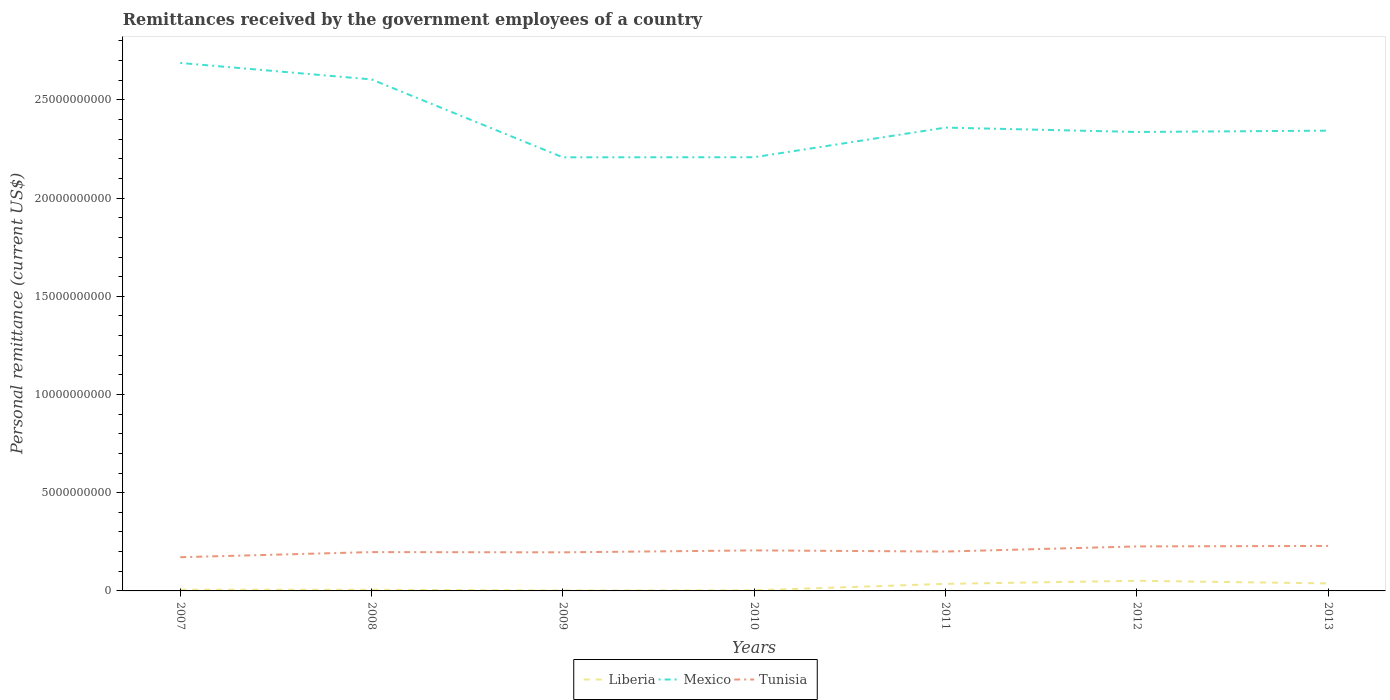How many different coloured lines are there?
Keep it short and to the point. 3. Does the line corresponding to Tunisia intersect with the line corresponding to Liberia?
Provide a short and direct response. No. Is the number of lines equal to the number of legend labels?
Give a very brief answer. Yes. Across all years, what is the maximum remittances received by the government employees in Mexico?
Give a very brief answer. 2.21e+1. What is the total remittances received by the government employees in Tunisia in the graph?
Ensure brevity in your answer.  -5.75e+08. What is the difference between the highest and the second highest remittances received by the government employees in Mexico?
Your answer should be compact. 4.80e+09. What is the difference between the highest and the lowest remittances received by the government employees in Mexico?
Provide a short and direct response. 2. How many years are there in the graph?
Your answer should be compact. 7. Does the graph contain any zero values?
Offer a very short reply. No. Does the graph contain grids?
Give a very brief answer. No. What is the title of the graph?
Provide a succinct answer. Remittances received by the government employees of a country. Does "Jamaica" appear as one of the legend labels in the graph?
Offer a very short reply. No. What is the label or title of the X-axis?
Give a very brief answer. Years. What is the label or title of the Y-axis?
Provide a succinct answer. Personal remittance (current US$). What is the Personal remittance (current US$) of Liberia in 2007?
Offer a very short reply. 6.20e+07. What is the Personal remittance (current US$) of Mexico in 2007?
Keep it short and to the point. 2.69e+1. What is the Personal remittance (current US$) in Tunisia in 2007?
Offer a very short reply. 1.72e+09. What is the Personal remittance (current US$) of Liberia in 2008?
Your answer should be very brief. 5.81e+07. What is the Personal remittance (current US$) of Mexico in 2008?
Provide a succinct answer. 2.60e+1. What is the Personal remittance (current US$) of Tunisia in 2008?
Your answer should be very brief. 1.98e+09. What is the Personal remittance (current US$) in Liberia in 2009?
Give a very brief answer. 2.51e+07. What is the Personal remittance (current US$) of Mexico in 2009?
Offer a very short reply. 2.21e+1. What is the Personal remittance (current US$) in Tunisia in 2009?
Your response must be concise. 1.96e+09. What is the Personal remittance (current US$) in Liberia in 2010?
Give a very brief answer. 3.14e+07. What is the Personal remittance (current US$) of Mexico in 2010?
Offer a terse response. 2.21e+1. What is the Personal remittance (current US$) in Tunisia in 2010?
Your answer should be very brief. 2.06e+09. What is the Personal remittance (current US$) of Liberia in 2011?
Ensure brevity in your answer.  3.60e+08. What is the Personal remittance (current US$) in Mexico in 2011?
Offer a very short reply. 2.36e+1. What is the Personal remittance (current US$) of Tunisia in 2011?
Make the answer very short. 2.00e+09. What is the Personal remittance (current US$) of Liberia in 2012?
Your response must be concise. 5.16e+08. What is the Personal remittance (current US$) in Mexico in 2012?
Provide a short and direct response. 2.34e+1. What is the Personal remittance (current US$) in Tunisia in 2012?
Provide a short and direct response. 2.27e+09. What is the Personal remittance (current US$) in Liberia in 2013?
Provide a short and direct response. 3.83e+08. What is the Personal remittance (current US$) in Mexico in 2013?
Give a very brief answer. 2.34e+1. What is the Personal remittance (current US$) in Tunisia in 2013?
Make the answer very short. 2.29e+09. Across all years, what is the maximum Personal remittance (current US$) in Liberia?
Give a very brief answer. 5.16e+08. Across all years, what is the maximum Personal remittance (current US$) of Mexico?
Provide a short and direct response. 2.69e+1. Across all years, what is the maximum Personal remittance (current US$) of Tunisia?
Offer a terse response. 2.29e+09. Across all years, what is the minimum Personal remittance (current US$) of Liberia?
Offer a very short reply. 2.51e+07. Across all years, what is the minimum Personal remittance (current US$) in Mexico?
Give a very brief answer. 2.21e+1. Across all years, what is the minimum Personal remittance (current US$) of Tunisia?
Ensure brevity in your answer.  1.72e+09. What is the total Personal remittance (current US$) in Liberia in the graph?
Offer a terse response. 1.44e+09. What is the total Personal remittance (current US$) of Mexico in the graph?
Provide a short and direct response. 1.67e+11. What is the total Personal remittance (current US$) of Tunisia in the graph?
Your answer should be compact. 1.43e+1. What is the difference between the Personal remittance (current US$) of Liberia in 2007 and that in 2008?
Your answer should be compact. 3.85e+06. What is the difference between the Personal remittance (current US$) of Mexico in 2007 and that in 2008?
Offer a terse response. 8.38e+08. What is the difference between the Personal remittance (current US$) of Tunisia in 2007 and that in 2008?
Keep it short and to the point. -2.61e+08. What is the difference between the Personal remittance (current US$) in Liberia in 2007 and that in 2009?
Provide a succinct answer. 3.69e+07. What is the difference between the Personal remittance (current US$) in Mexico in 2007 and that in 2009?
Your answer should be compact. 4.80e+09. What is the difference between the Personal remittance (current US$) in Tunisia in 2007 and that in 2009?
Offer a terse response. -2.49e+08. What is the difference between the Personal remittance (current US$) in Liberia in 2007 and that in 2010?
Provide a succinct answer. 3.05e+07. What is the difference between the Personal remittance (current US$) in Mexico in 2007 and that in 2010?
Make the answer very short. 4.80e+09. What is the difference between the Personal remittance (current US$) in Tunisia in 2007 and that in 2010?
Your answer should be compact. -3.48e+08. What is the difference between the Personal remittance (current US$) in Liberia in 2007 and that in 2011?
Your answer should be compact. -2.98e+08. What is the difference between the Personal remittance (current US$) in Mexico in 2007 and that in 2011?
Offer a very short reply. 3.29e+09. What is the difference between the Personal remittance (current US$) of Tunisia in 2007 and that in 2011?
Your response must be concise. -2.89e+08. What is the difference between the Personal remittance (current US$) of Liberia in 2007 and that in 2012?
Your response must be concise. -4.54e+08. What is the difference between the Personal remittance (current US$) in Mexico in 2007 and that in 2012?
Offer a terse response. 3.51e+09. What is the difference between the Personal remittance (current US$) of Tunisia in 2007 and that in 2012?
Provide a short and direct response. -5.50e+08. What is the difference between the Personal remittance (current US$) in Liberia in 2007 and that in 2013?
Ensure brevity in your answer.  -3.21e+08. What is the difference between the Personal remittance (current US$) of Mexico in 2007 and that in 2013?
Keep it short and to the point. 3.45e+09. What is the difference between the Personal remittance (current US$) of Tunisia in 2007 and that in 2013?
Offer a very short reply. -5.75e+08. What is the difference between the Personal remittance (current US$) of Liberia in 2008 and that in 2009?
Provide a succinct answer. 3.30e+07. What is the difference between the Personal remittance (current US$) in Mexico in 2008 and that in 2009?
Provide a short and direct response. 3.97e+09. What is the difference between the Personal remittance (current US$) of Tunisia in 2008 and that in 2009?
Your response must be concise. 1.25e+07. What is the difference between the Personal remittance (current US$) of Liberia in 2008 and that in 2010?
Offer a very short reply. 2.67e+07. What is the difference between the Personal remittance (current US$) in Mexico in 2008 and that in 2010?
Your answer should be compact. 3.96e+09. What is the difference between the Personal remittance (current US$) of Tunisia in 2008 and that in 2010?
Ensure brevity in your answer.  -8.63e+07. What is the difference between the Personal remittance (current US$) of Liberia in 2008 and that in 2011?
Offer a terse response. -3.02e+08. What is the difference between the Personal remittance (current US$) of Mexico in 2008 and that in 2011?
Your answer should be compact. 2.45e+09. What is the difference between the Personal remittance (current US$) in Tunisia in 2008 and that in 2011?
Provide a short and direct response. -2.75e+07. What is the difference between the Personal remittance (current US$) of Liberia in 2008 and that in 2012?
Offer a very short reply. -4.58e+08. What is the difference between the Personal remittance (current US$) of Mexico in 2008 and that in 2012?
Give a very brief answer. 2.68e+09. What is the difference between the Personal remittance (current US$) in Tunisia in 2008 and that in 2012?
Your answer should be very brief. -2.89e+08. What is the difference between the Personal remittance (current US$) in Liberia in 2008 and that in 2013?
Keep it short and to the point. -3.25e+08. What is the difference between the Personal remittance (current US$) of Mexico in 2008 and that in 2013?
Give a very brief answer. 2.61e+09. What is the difference between the Personal remittance (current US$) of Tunisia in 2008 and that in 2013?
Your response must be concise. -3.14e+08. What is the difference between the Personal remittance (current US$) of Liberia in 2009 and that in 2010?
Your response must be concise. -6.33e+06. What is the difference between the Personal remittance (current US$) in Mexico in 2009 and that in 2010?
Offer a terse response. -4.52e+06. What is the difference between the Personal remittance (current US$) in Tunisia in 2009 and that in 2010?
Give a very brief answer. -9.88e+07. What is the difference between the Personal remittance (current US$) of Liberia in 2009 and that in 2011?
Ensure brevity in your answer.  -3.35e+08. What is the difference between the Personal remittance (current US$) in Mexico in 2009 and that in 2011?
Make the answer very short. -1.51e+09. What is the difference between the Personal remittance (current US$) of Tunisia in 2009 and that in 2011?
Provide a succinct answer. -4.00e+07. What is the difference between the Personal remittance (current US$) of Liberia in 2009 and that in 2012?
Ensure brevity in your answer.  -4.91e+08. What is the difference between the Personal remittance (current US$) in Mexico in 2009 and that in 2012?
Give a very brief answer. -1.29e+09. What is the difference between the Personal remittance (current US$) of Tunisia in 2009 and that in 2012?
Give a very brief answer. -3.01e+08. What is the difference between the Personal remittance (current US$) of Liberia in 2009 and that in 2013?
Give a very brief answer. -3.58e+08. What is the difference between the Personal remittance (current US$) in Mexico in 2009 and that in 2013?
Offer a terse response. -1.36e+09. What is the difference between the Personal remittance (current US$) of Tunisia in 2009 and that in 2013?
Your answer should be compact. -3.26e+08. What is the difference between the Personal remittance (current US$) of Liberia in 2010 and that in 2011?
Offer a very short reply. -3.29e+08. What is the difference between the Personal remittance (current US$) of Mexico in 2010 and that in 2011?
Your answer should be compact. -1.51e+09. What is the difference between the Personal remittance (current US$) of Tunisia in 2010 and that in 2011?
Offer a very short reply. 5.88e+07. What is the difference between the Personal remittance (current US$) in Liberia in 2010 and that in 2012?
Provide a succinct answer. -4.84e+08. What is the difference between the Personal remittance (current US$) of Mexico in 2010 and that in 2012?
Ensure brevity in your answer.  -1.29e+09. What is the difference between the Personal remittance (current US$) of Tunisia in 2010 and that in 2012?
Give a very brief answer. -2.02e+08. What is the difference between the Personal remittance (current US$) of Liberia in 2010 and that in 2013?
Your answer should be very brief. -3.52e+08. What is the difference between the Personal remittance (current US$) in Mexico in 2010 and that in 2013?
Ensure brevity in your answer.  -1.35e+09. What is the difference between the Personal remittance (current US$) of Tunisia in 2010 and that in 2013?
Make the answer very short. -2.27e+08. What is the difference between the Personal remittance (current US$) in Liberia in 2011 and that in 2012?
Offer a very short reply. -1.56e+08. What is the difference between the Personal remittance (current US$) in Mexico in 2011 and that in 2012?
Keep it short and to the point. 2.22e+08. What is the difference between the Personal remittance (current US$) of Tunisia in 2011 and that in 2012?
Make the answer very short. -2.61e+08. What is the difference between the Personal remittance (current US$) of Liberia in 2011 and that in 2013?
Your answer should be very brief. -2.34e+07. What is the difference between the Personal remittance (current US$) in Mexico in 2011 and that in 2013?
Provide a succinct answer. 1.56e+08. What is the difference between the Personal remittance (current US$) in Tunisia in 2011 and that in 2013?
Your answer should be very brief. -2.86e+08. What is the difference between the Personal remittance (current US$) of Liberia in 2012 and that in 2013?
Your response must be concise. 1.32e+08. What is the difference between the Personal remittance (current US$) of Mexico in 2012 and that in 2013?
Your answer should be very brief. -6.69e+07. What is the difference between the Personal remittance (current US$) in Tunisia in 2012 and that in 2013?
Offer a very short reply. -2.48e+07. What is the difference between the Personal remittance (current US$) of Liberia in 2007 and the Personal remittance (current US$) of Mexico in 2008?
Offer a terse response. -2.60e+1. What is the difference between the Personal remittance (current US$) of Liberia in 2007 and the Personal remittance (current US$) of Tunisia in 2008?
Keep it short and to the point. -1.91e+09. What is the difference between the Personal remittance (current US$) in Mexico in 2007 and the Personal remittance (current US$) in Tunisia in 2008?
Give a very brief answer. 2.49e+1. What is the difference between the Personal remittance (current US$) of Liberia in 2007 and the Personal remittance (current US$) of Mexico in 2009?
Ensure brevity in your answer.  -2.20e+1. What is the difference between the Personal remittance (current US$) in Liberia in 2007 and the Personal remittance (current US$) in Tunisia in 2009?
Give a very brief answer. -1.90e+09. What is the difference between the Personal remittance (current US$) in Mexico in 2007 and the Personal remittance (current US$) in Tunisia in 2009?
Ensure brevity in your answer.  2.49e+1. What is the difference between the Personal remittance (current US$) of Liberia in 2007 and the Personal remittance (current US$) of Mexico in 2010?
Offer a terse response. -2.20e+1. What is the difference between the Personal remittance (current US$) in Liberia in 2007 and the Personal remittance (current US$) in Tunisia in 2010?
Give a very brief answer. -2.00e+09. What is the difference between the Personal remittance (current US$) in Mexico in 2007 and the Personal remittance (current US$) in Tunisia in 2010?
Provide a short and direct response. 2.48e+1. What is the difference between the Personal remittance (current US$) of Liberia in 2007 and the Personal remittance (current US$) of Mexico in 2011?
Ensure brevity in your answer.  -2.35e+1. What is the difference between the Personal remittance (current US$) in Liberia in 2007 and the Personal remittance (current US$) in Tunisia in 2011?
Ensure brevity in your answer.  -1.94e+09. What is the difference between the Personal remittance (current US$) of Mexico in 2007 and the Personal remittance (current US$) of Tunisia in 2011?
Your answer should be compact. 2.49e+1. What is the difference between the Personal remittance (current US$) in Liberia in 2007 and the Personal remittance (current US$) in Mexico in 2012?
Make the answer very short. -2.33e+1. What is the difference between the Personal remittance (current US$) of Liberia in 2007 and the Personal remittance (current US$) of Tunisia in 2012?
Offer a very short reply. -2.20e+09. What is the difference between the Personal remittance (current US$) in Mexico in 2007 and the Personal remittance (current US$) in Tunisia in 2012?
Give a very brief answer. 2.46e+1. What is the difference between the Personal remittance (current US$) in Liberia in 2007 and the Personal remittance (current US$) in Mexico in 2013?
Your response must be concise. -2.34e+1. What is the difference between the Personal remittance (current US$) of Liberia in 2007 and the Personal remittance (current US$) of Tunisia in 2013?
Give a very brief answer. -2.23e+09. What is the difference between the Personal remittance (current US$) of Mexico in 2007 and the Personal remittance (current US$) of Tunisia in 2013?
Give a very brief answer. 2.46e+1. What is the difference between the Personal remittance (current US$) in Liberia in 2008 and the Personal remittance (current US$) in Mexico in 2009?
Ensure brevity in your answer.  -2.20e+1. What is the difference between the Personal remittance (current US$) in Liberia in 2008 and the Personal remittance (current US$) in Tunisia in 2009?
Offer a terse response. -1.91e+09. What is the difference between the Personal remittance (current US$) of Mexico in 2008 and the Personal remittance (current US$) of Tunisia in 2009?
Ensure brevity in your answer.  2.41e+1. What is the difference between the Personal remittance (current US$) of Liberia in 2008 and the Personal remittance (current US$) of Mexico in 2010?
Give a very brief answer. -2.20e+1. What is the difference between the Personal remittance (current US$) of Liberia in 2008 and the Personal remittance (current US$) of Tunisia in 2010?
Provide a succinct answer. -2.01e+09. What is the difference between the Personal remittance (current US$) in Mexico in 2008 and the Personal remittance (current US$) in Tunisia in 2010?
Offer a very short reply. 2.40e+1. What is the difference between the Personal remittance (current US$) in Liberia in 2008 and the Personal remittance (current US$) in Mexico in 2011?
Your answer should be compact. -2.35e+1. What is the difference between the Personal remittance (current US$) of Liberia in 2008 and the Personal remittance (current US$) of Tunisia in 2011?
Offer a very short reply. -1.95e+09. What is the difference between the Personal remittance (current US$) in Mexico in 2008 and the Personal remittance (current US$) in Tunisia in 2011?
Your answer should be very brief. 2.40e+1. What is the difference between the Personal remittance (current US$) in Liberia in 2008 and the Personal remittance (current US$) in Mexico in 2012?
Provide a short and direct response. -2.33e+1. What is the difference between the Personal remittance (current US$) of Liberia in 2008 and the Personal remittance (current US$) of Tunisia in 2012?
Make the answer very short. -2.21e+09. What is the difference between the Personal remittance (current US$) of Mexico in 2008 and the Personal remittance (current US$) of Tunisia in 2012?
Make the answer very short. 2.38e+1. What is the difference between the Personal remittance (current US$) in Liberia in 2008 and the Personal remittance (current US$) in Mexico in 2013?
Provide a succinct answer. -2.34e+1. What is the difference between the Personal remittance (current US$) of Liberia in 2008 and the Personal remittance (current US$) of Tunisia in 2013?
Offer a terse response. -2.23e+09. What is the difference between the Personal remittance (current US$) of Mexico in 2008 and the Personal remittance (current US$) of Tunisia in 2013?
Provide a short and direct response. 2.38e+1. What is the difference between the Personal remittance (current US$) of Liberia in 2009 and the Personal remittance (current US$) of Mexico in 2010?
Offer a very short reply. -2.21e+1. What is the difference between the Personal remittance (current US$) in Liberia in 2009 and the Personal remittance (current US$) in Tunisia in 2010?
Offer a terse response. -2.04e+09. What is the difference between the Personal remittance (current US$) in Mexico in 2009 and the Personal remittance (current US$) in Tunisia in 2010?
Provide a short and direct response. 2.00e+1. What is the difference between the Personal remittance (current US$) in Liberia in 2009 and the Personal remittance (current US$) in Mexico in 2011?
Your answer should be compact. -2.36e+1. What is the difference between the Personal remittance (current US$) of Liberia in 2009 and the Personal remittance (current US$) of Tunisia in 2011?
Your answer should be very brief. -1.98e+09. What is the difference between the Personal remittance (current US$) of Mexico in 2009 and the Personal remittance (current US$) of Tunisia in 2011?
Offer a terse response. 2.01e+1. What is the difference between the Personal remittance (current US$) of Liberia in 2009 and the Personal remittance (current US$) of Mexico in 2012?
Make the answer very short. -2.33e+1. What is the difference between the Personal remittance (current US$) in Liberia in 2009 and the Personal remittance (current US$) in Tunisia in 2012?
Provide a succinct answer. -2.24e+09. What is the difference between the Personal remittance (current US$) of Mexico in 2009 and the Personal remittance (current US$) of Tunisia in 2012?
Give a very brief answer. 1.98e+1. What is the difference between the Personal remittance (current US$) of Liberia in 2009 and the Personal remittance (current US$) of Mexico in 2013?
Keep it short and to the point. -2.34e+1. What is the difference between the Personal remittance (current US$) in Liberia in 2009 and the Personal remittance (current US$) in Tunisia in 2013?
Ensure brevity in your answer.  -2.27e+09. What is the difference between the Personal remittance (current US$) of Mexico in 2009 and the Personal remittance (current US$) of Tunisia in 2013?
Give a very brief answer. 1.98e+1. What is the difference between the Personal remittance (current US$) in Liberia in 2010 and the Personal remittance (current US$) in Mexico in 2011?
Your response must be concise. -2.36e+1. What is the difference between the Personal remittance (current US$) of Liberia in 2010 and the Personal remittance (current US$) of Tunisia in 2011?
Offer a very short reply. -1.97e+09. What is the difference between the Personal remittance (current US$) in Mexico in 2010 and the Personal remittance (current US$) in Tunisia in 2011?
Make the answer very short. 2.01e+1. What is the difference between the Personal remittance (current US$) in Liberia in 2010 and the Personal remittance (current US$) in Mexico in 2012?
Provide a succinct answer. -2.33e+1. What is the difference between the Personal remittance (current US$) in Liberia in 2010 and the Personal remittance (current US$) in Tunisia in 2012?
Make the answer very short. -2.23e+09. What is the difference between the Personal remittance (current US$) in Mexico in 2010 and the Personal remittance (current US$) in Tunisia in 2012?
Provide a short and direct response. 1.98e+1. What is the difference between the Personal remittance (current US$) of Liberia in 2010 and the Personal remittance (current US$) of Mexico in 2013?
Provide a succinct answer. -2.34e+1. What is the difference between the Personal remittance (current US$) in Liberia in 2010 and the Personal remittance (current US$) in Tunisia in 2013?
Your answer should be compact. -2.26e+09. What is the difference between the Personal remittance (current US$) in Mexico in 2010 and the Personal remittance (current US$) in Tunisia in 2013?
Your response must be concise. 1.98e+1. What is the difference between the Personal remittance (current US$) of Liberia in 2011 and the Personal remittance (current US$) of Mexico in 2012?
Provide a succinct answer. -2.30e+1. What is the difference between the Personal remittance (current US$) in Liberia in 2011 and the Personal remittance (current US$) in Tunisia in 2012?
Offer a very short reply. -1.91e+09. What is the difference between the Personal remittance (current US$) of Mexico in 2011 and the Personal remittance (current US$) of Tunisia in 2012?
Offer a very short reply. 2.13e+1. What is the difference between the Personal remittance (current US$) in Liberia in 2011 and the Personal remittance (current US$) in Mexico in 2013?
Your response must be concise. -2.31e+1. What is the difference between the Personal remittance (current US$) of Liberia in 2011 and the Personal remittance (current US$) of Tunisia in 2013?
Offer a terse response. -1.93e+09. What is the difference between the Personal remittance (current US$) in Mexico in 2011 and the Personal remittance (current US$) in Tunisia in 2013?
Make the answer very short. 2.13e+1. What is the difference between the Personal remittance (current US$) of Liberia in 2012 and the Personal remittance (current US$) of Mexico in 2013?
Your answer should be very brief. -2.29e+1. What is the difference between the Personal remittance (current US$) of Liberia in 2012 and the Personal remittance (current US$) of Tunisia in 2013?
Your response must be concise. -1.77e+09. What is the difference between the Personal remittance (current US$) in Mexico in 2012 and the Personal remittance (current US$) in Tunisia in 2013?
Give a very brief answer. 2.11e+1. What is the average Personal remittance (current US$) of Liberia per year?
Provide a succinct answer. 2.05e+08. What is the average Personal remittance (current US$) of Mexico per year?
Your response must be concise. 2.39e+1. What is the average Personal remittance (current US$) in Tunisia per year?
Provide a short and direct response. 2.04e+09. In the year 2007, what is the difference between the Personal remittance (current US$) of Liberia and Personal remittance (current US$) of Mexico?
Ensure brevity in your answer.  -2.68e+1. In the year 2007, what is the difference between the Personal remittance (current US$) in Liberia and Personal remittance (current US$) in Tunisia?
Your response must be concise. -1.65e+09. In the year 2007, what is the difference between the Personal remittance (current US$) in Mexico and Personal remittance (current US$) in Tunisia?
Provide a short and direct response. 2.52e+1. In the year 2008, what is the difference between the Personal remittance (current US$) in Liberia and Personal remittance (current US$) in Mexico?
Keep it short and to the point. -2.60e+1. In the year 2008, what is the difference between the Personal remittance (current US$) in Liberia and Personal remittance (current US$) in Tunisia?
Provide a short and direct response. -1.92e+09. In the year 2008, what is the difference between the Personal remittance (current US$) of Mexico and Personal remittance (current US$) of Tunisia?
Your response must be concise. 2.41e+1. In the year 2009, what is the difference between the Personal remittance (current US$) in Liberia and Personal remittance (current US$) in Mexico?
Offer a terse response. -2.21e+1. In the year 2009, what is the difference between the Personal remittance (current US$) of Liberia and Personal remittance (current US$) of Tunisia?
Provide a succinct answer. -1.94e+09. In the year 2009, what is the difference between the Personal remittance (current US$) in Mexico and Personal remittance (current US$) in Tunisia?
Ensure brevity in your answer.  2.01e+1. In the year 2010, what is the difference between the Personal remittance (current US$) in Liberia and Personal remittance (current US$) in Mexico?
Keep it short and to the point. -2.20e+1. In the year 2010, what is the difference between the Personal remittance (current US$) of Liberia and Personal remittance (current US$) of Tunisia?
Your answer should be compact. -2.03e+09. In the year 2010, what is the difference between the Personal remittance (current US$) of Mexico and Personal remittance (current US$) of Tunisia?
Your response must be concise. 2.00e+1. In the year 2011, what is the difference between the Personal remittance (current US$) of Liberia and Personal remittance (current US$) of Mexico?
Ensure brevity in your answer.  -2.32e+1. In the year 2011, what is the difference between the Personal remittance (current US$) of Liberia and Personal remittance (current US$) of Tunisia?
Offer a terse response. -1.64e+09. In the year 2011, what is the difference between the Personal remittance (current US$) of Mexico and Personal remittance (current US$) of Tunisia?
Your answer should be very brief. 2.16e+1. In the year 2012, what is the difference between the Personal remittance (current US$) of Liberia and Personal remittance (current US$) of Mexico?
Make the answer very short. -2.29e+1. In the year 2012, what is the difference between the Personal remittance (current US$) in Liberia and Personal remittance (current US$) in Tunisia?
Provide a succinct answer. -1.75e+09. In the year 2012, what is the difference between the Personal remittance (current US$) of Mexico and Personal remittance (current US$) of Tunisia?
Offer a very short reply. 2.11e+1. In the year 2013, what is the difference between the Personal remittance (current US$) of Liberia and Personal remittance (current US$) of Mexico?
Offer a very short reply. -2.30e+1. In the year 2013, what is the difference between the Personal remittance (current US$) of Liberia and Personal remittance (current US$) of Tunisia?
Provide a succinct answer. -1.91e+09. In the year 2013, what is the difference between the Personal remittance (current US$) in Mexico and Personal remittance (current US$) in Tunisia?
Offer a terse response. 2.11e+1. What is the ratio of the Personal remittance (current US$) in Liberia in 2007 to that in 2008?
Make the answer very short. 1.07. What is the ratio of the Personal remittance (current US$) in Mexico in 2007 to that in 2008?
Provide a succinct answer. 1.03. What is the ratio of the Personal remittance (current US$) in Tunisia in 2007 to that in 2008?
Ensure brevity in your answer.  0.87. What is the ratio of the Personal remittance (current US$) of Liberia in 2007 to that in 2009?
Your answer should be compact. 2.47. What is the ratio of the Personal remittance (current US$) of Mexico in 2007 to that in 2009?
Your response must be concise. 1.22. What is the ratio of the Personal remittance (current US$) of Tunisia in 2007 to that in 2009?
Make the answer very short. 0.87. What is the ratio of the Personal remittance (current US$) of Liberia in 2007 to that in 2010?
Make the answer very short. 1.97. What is the ratio of the Personal remittance (current US$) of Mexico in 2007 to that in 2010?
Provide a short and direct response. 1.22. What is the ratio of the Personal remittance (current US$) in Tunisia in 2007 to that in 2010?
Your response must be concise. 0.83. What is the ratio of the Personal remittance (current US$) of Liberia in 2007 to that in 2011?
Provide a short and direct response. 0.17. What is the ratio of the Personal remittance (current US$) in Mexico in 2007 to that in 2011?
Your response must be concise. 1.14. What is the ratio of the Personal remittance (current US$) in Tunisia in 2007 to that in 2011?
Offer a very short reply. 0.86. What is the ratio of the Personal remittance (current US$) in Liberia in 2007 to that in 2012?
Make the answer very short. 0.12. What is the ratio of the Personal remittance (current US$) of Mexico in 2007 to that in 2012?
Keep it short and to the point. 1.15. What is the ratio of the Personal remittance (current US$) in Tunisia in 2007 to that in 2012?
Ensure brevity in your answer.  0.76. What is the ratio of the Personal remittance (current US$) of Liberia in 2007 to that in 2013?
Offer a terse response. 0.16. What is the ratio of the Personal remittance (current US$) in Mexico in 2007 to that in 2013?
Offer a terse response. 1.15. What is the ratio of the Personal remittance (current US$) of Tunisia in 2007 to that in 2013?
Provide a succinct answer. 0.75. What is the ratio of the Personal remittance (current US$) in Liberia in 2008 to that in 2009?
Make the answer very short. 2.31. What is the ratio of the Personal remittance (current US$) of Mexico in 2008 to that in 2009?
Offer a terse response. 1.18. What is the ratio of the Personal remittance (current US$) of Tunisia in 2008 to that in 2009?
Provide a succinct answer. 1.01. What is the ratio of the Personal remittance (current US$) in Liberia in 2008 to that in 2010?
Your response must be concise. 1.85. What is the ratio of the Personal remittance (current US$) of Mexico in 2008 to that in 2010?
Keep it short and to the point. 1.18. What is the ratio of the Personal remittance (current US$) of Tunisia in 2008 to that in 2010?
Your answer should be very brief. 0.96. What is the ratio of the Personal remittance (current US$) of Liberia in 2008 to that in 2011?
Offer a terse response. 0.16. What is the ratio of the Personal remittance (current US$) of Mexico in 2008 to that in 2011?
Ensure brevity in your answer.  1.1. What is the ratio of the Personal remittance (current US$) of Tunisia in 2008 to that in 2011?
Provide a short and direct response. 0.99. What is the ratio of the Personal remittance (current US$) of Liberia in 2008 to that in 2012?
Offer a very short reply. 0.11. What is the ratio of the Personal remittance (current US$) of Mexico in 2008 to that in 2012?
Provide a succinct answer. 1.11. What is the ratio of the Personal remittance (current US$) in Tunisia in 2008 to that in 2012?
Make the answer very short. 0.87. What is the ratio of the Personal remittance (current US$) in Liberia in 2008 to that in 2013?
Provide a succinct answer. 0.15. What is the ratio of the Personal remittance (current US$) of Mexico in 2008 to that in 2013?
Provide a succinct answer. 1.11. What is the ratio of the Personal remittance (current US$) of Tunisia in 2008 to that in 2013?
Give a very brief answer. 0.86. What is the ratio of the Personal remittance (current US$) of Liberia in 2009 to that in 2010?
Keep it short and to the point. 0.8. What is the ratio of the Personal remittance (current US$) in Tunisia in 2009 to that in 2010?
Give a very brief answer. 0.95. What is the ratio of the Personal remittance (current US$) in Liberia in 2009 to that in 2011?
Ensure brevity in your answer.  0.07. What is the ratio of the Personal remittance (current US$) of Mexico in 2009 to that in 2011?
Make the answer very short. 0.94. What is the ratio of the Personal remittance (current US$) of Liberia in 2009 to that in 2012?
Provide a succinct answer. 0.05. What is the ratio of the Personal remittance (current US$) of Mexico in 2009 to that in 2012?
Make the answer very short. 0.94. What is the ratio of the Personal remittance (current US$) in Tunisia in 2009 to that in 2012?
Your answer should be compact. 0.87. What is the ratio of the Personal remittance (current US$) in Liberia in 2009 to that in 2013?
Your answer should be compact. 0.07. What is the ratio of the Personal remittance (current US$) in Mexico in 2009 to that in 2013?
Keep it short and to the point. 0.94. What is the ratio of the Personal remittance (current US$) of Tunisia in 2009 to that in 2013?
Your answer should be very brief. 0.86. What is the ratio of the Personal remittance (current US$) of Liberia in 2010 to that in 2011?
Provide a succinct answer. 0.09. What is the ratio of the Personal remittance (current US$) in Mexico in 2010 to that in 2011?
Your answer should be very brief. 0.94. What is the ratio of the Personal remittance (current US$) in Tunisia in 2010 to that in 2011?
Make the answer very short. 1.03. What is the ratio of the Personal remittance (current US$) of Liberia in 2010 to that in 2012?
Ensure brevity in your answer.  0.06. What is the ratio of the Personal remittance (current US$) of Mexico in 2010 to that in 2012?
Provide a succinct answer. 0.94. What is the ratio of the Personal remittance (current US$) in Tunisia in 2010 to that in 2012?
Ensure brevity in your answer.  0.91. What is the ratio of the Personal remittance (current US$) of Liberia in 2010 to that in 2013?
Give a very brief answer. 0.08. What is the ratio of the Personal remittance (current US$) in Mexico in 2010 to that in 2013?
Your response must be concise. 0.94. What is the ratio of the Personal remittance (current US$) in Tunisia in 2010 to that in 2013?
Make the answer very short. 0.9. What is the ratio of the Personal remittance (current US$) of Liberia in 2011 to that in 2012?
Make the answer very short. 0.7. What is the ratio of the Personal remittance (current US$) in Mexico in 2011 to that in 2012?
Ensure brevity in your answer.  1.01. What is the ratio of the Personal remittance (current US$) of Tunisia in 2011 to that in 2012?
Your response must be concise. 0.88. What is the ratio of the Personal remittance (current US$) of Liberia in 2011 to that in 2013?
Ensure brevity in your answer.  0.94. What is the ratio of the Personal remittance (current US$) in Mexico in 2011 to that in 2013?
Give a very brief answer. 1.01. What is the ratio of the Personal remittance (current US$) in Tunisia in 2011 to that in 2013?
Offer a very short reply. 0.88. What is the ratio of the Personal remittance (current US$) in Liberia in 2012 to that in 2013?
Provide a succinct answer. 1.35. What is the ratio of the Personal remittance (current US$) of Mexico in 2012 to that in 2013?
Provide a succinct answer. 1. What is the ratio of the Personal remittance (current US$) in Tunisia in 2012 to that in 2013?
Keep it short and to the point. 0.99. What is the difference between the highest and the second highest Personal remittance (current US$) of Liberia?
Your answer should be compact. 1.32e+08. What is the difference between the highest and the second highest Personal remittance (current US$) in Mexico?
Make the answer very short. 8.38e+08. What is the difference between the highest and the second highest Personal remittance (current US$) in Tunisia?
Offer a very short reply. 2.48e+07. What is the difference between the highest and the lowest Personal remittance (current US$) of Liberia?
Offer a very short reply. 4.91e+08. What is the difference between the highest and the lowest Personal remittance (current US$) in Mexico?
Offer a very short reply. 4.80e+09. What is the difference between the highest and the lowest Personal remittance (current US$) in Tunisia?
Your answer should be very brief. 5.75e+08. 